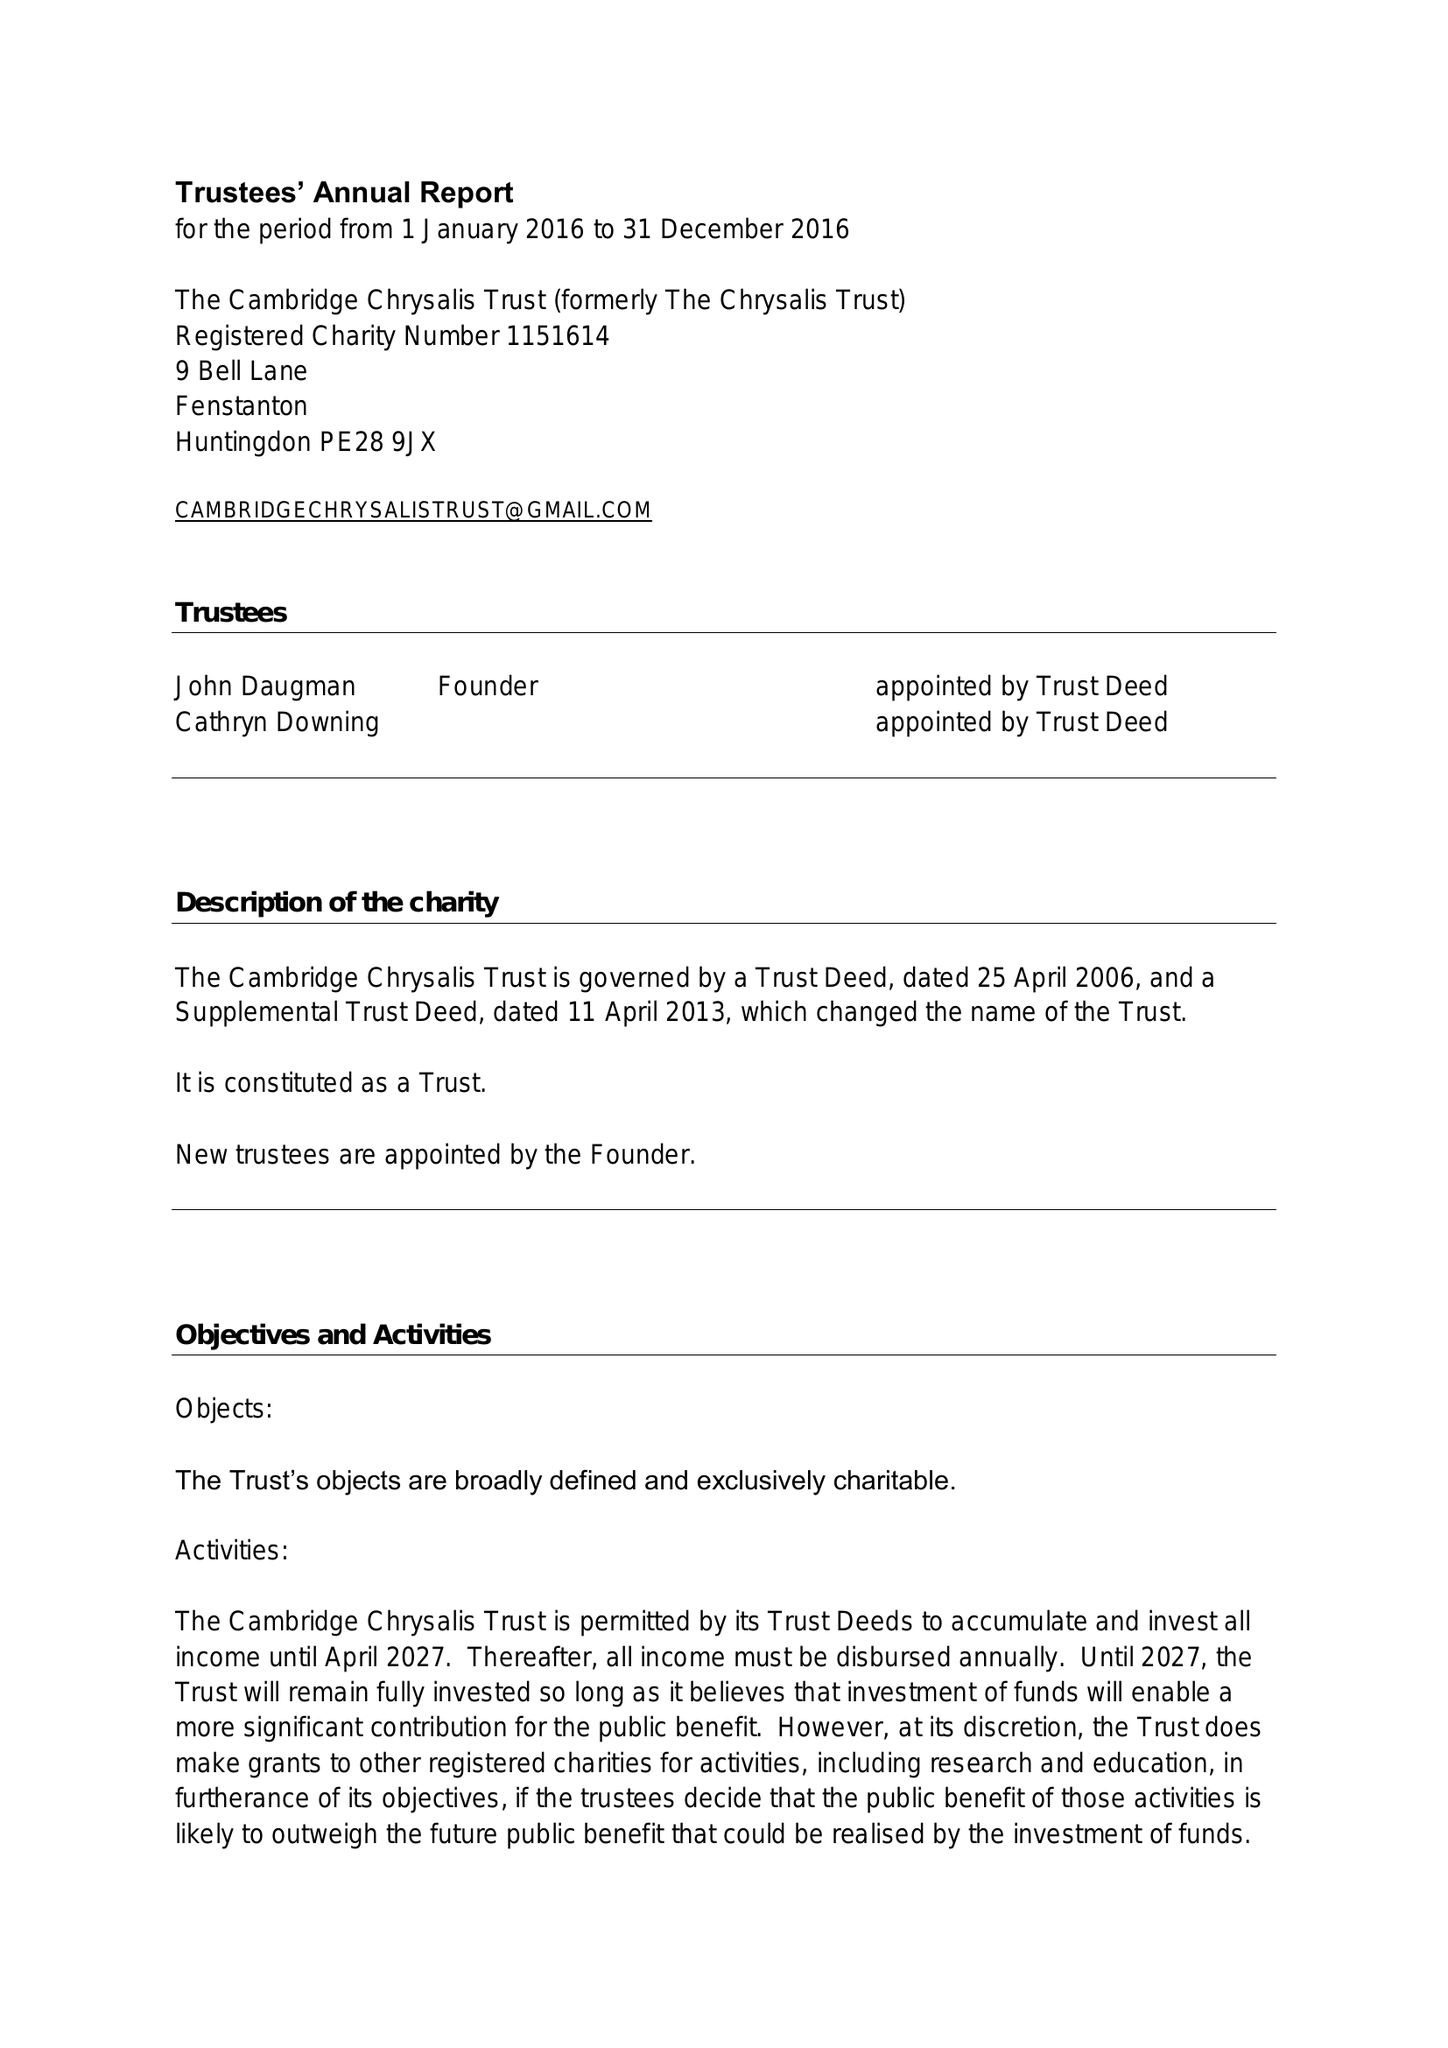What is the value for the report_date?
Answer the question using a single word or phrase. 2016-12-31 